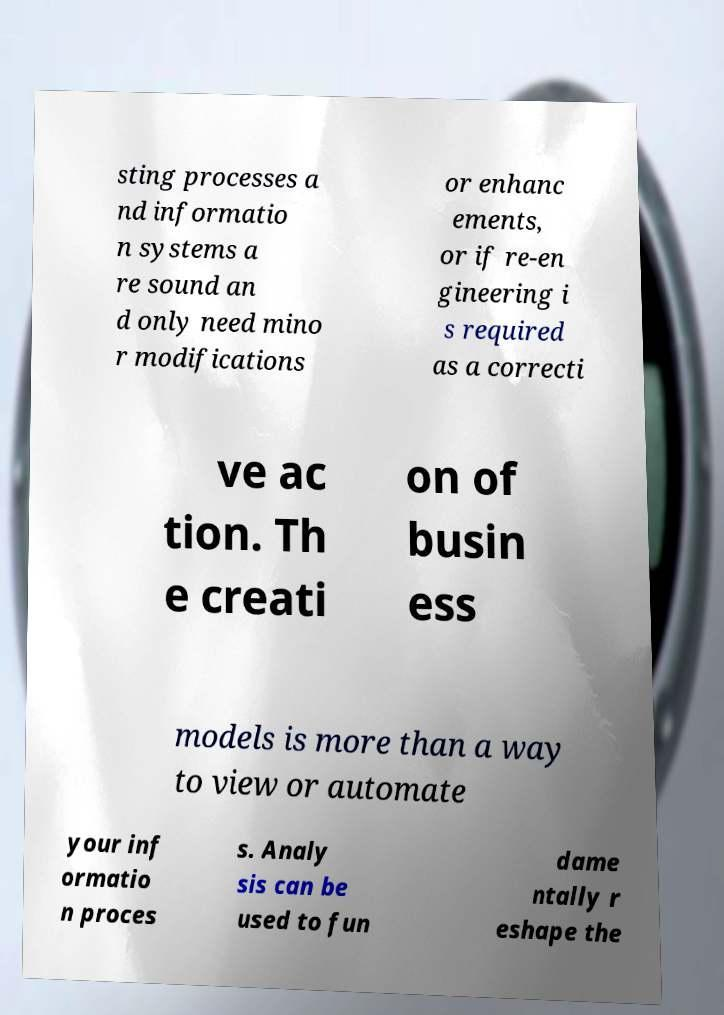For documentation purposes, I need the text within this image transcribed. Could you provide that? sting processes a nd informatio n systems a re sound an d only need mino r modifications or enhanc ements, or if re-en gineering i s required as a correcti ve ac tion. Th e creati on of busin ess models is more than a way to view or automate your inf ormatio n proces s. Analy sis can be used to fun dame ntally r eshape the 